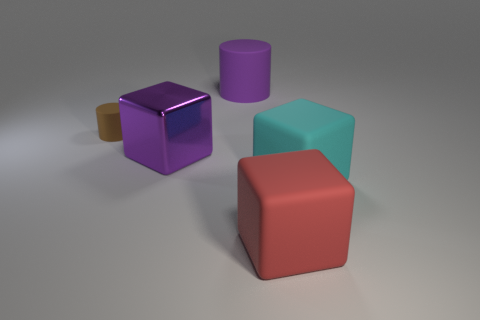Is there any other thing that is the same material as the purple block?
Offer a very short reply. No. The object that is behind the big shiny thing and in front of the purple rubber cylinder is made of what material?
Your response must be concise. Rubber. Are there any big red rubber things on the left side of the big cyan rubber cube?
Offer a very short reply. Yes. Are the large cyan object and the large purple cube made of the same material?
Make the answer very short. No. What is the material of the cylinder that is the same size as the cyan matte cube?
Offer a terse response. Rubber. What number of objects are cylinders that are to the right of the tiny brown thing or small blue matte balls?
Offer a terse response. 1. Is the number of rubber blocks that are right of the red thing the same as the number of rubber things?
Your answer should be very brief. No. Do the metal cube and the large rubber cylinder have the same color?
Your answer should be very brief. Yes. What is the color of the object that is both left of the big matte cylinder and in front of the small thing?
Provide a succinct answer. Purple. How many cylinders are red things or purple metal objects?
Provide a succinct answer. 0. 